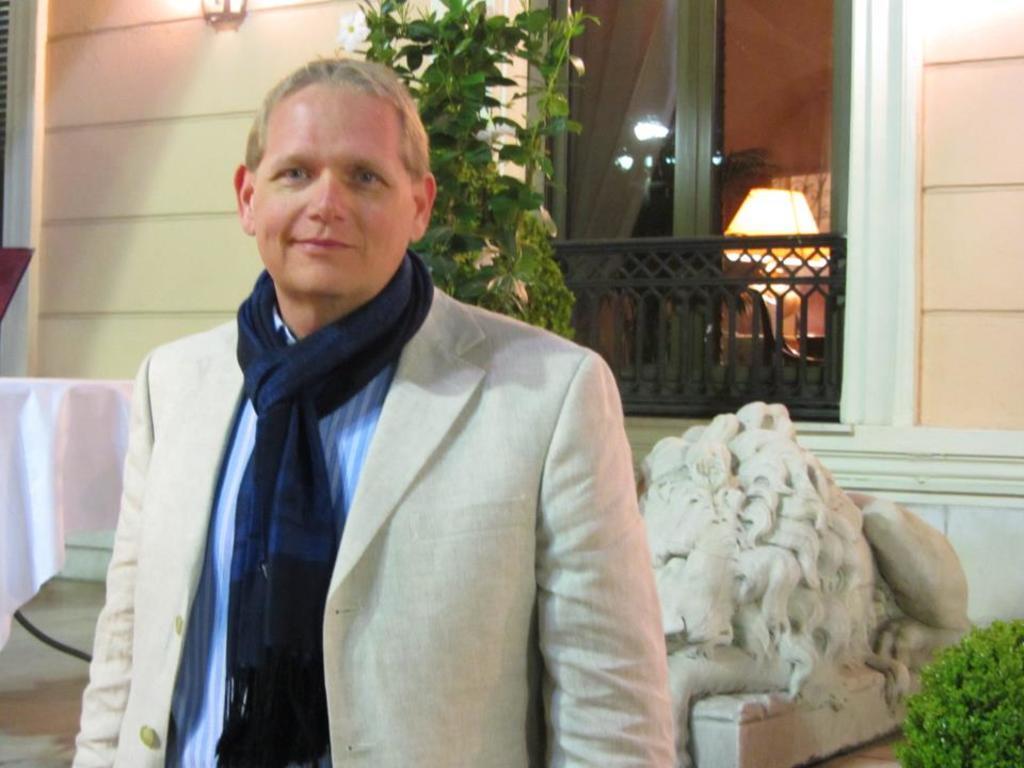Could you give a brief overview of what you see in this image? In the foreground of this image, there is a man in the suit standing and posing to the camera. In the background, there are plants, wall, window, light, sculpture like an object and a table. 